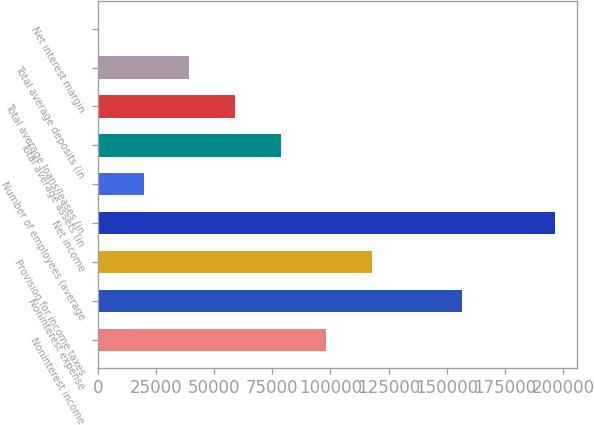Convert chart. <chart><loc_0><loc_0><loc_500><loc_500><bar_chart><fcel>Noninterest income<fcel>Noninterest expense<fcel>Provision for income taxes<fcel>Net income<fcel>Number of employees (average<fcel>Total average assets (in<fcel>Total average loans/leases (in<fcel>Total average deposits (in<fcel>Net interest margin<nl><fcel>98189.8<fcel>156715<fcel>117827<fcel>196377<fcel>19640<fcel>78552.4<fcel>58914.9<fcel>39277.5<fcel>2.61<nl></chart> 